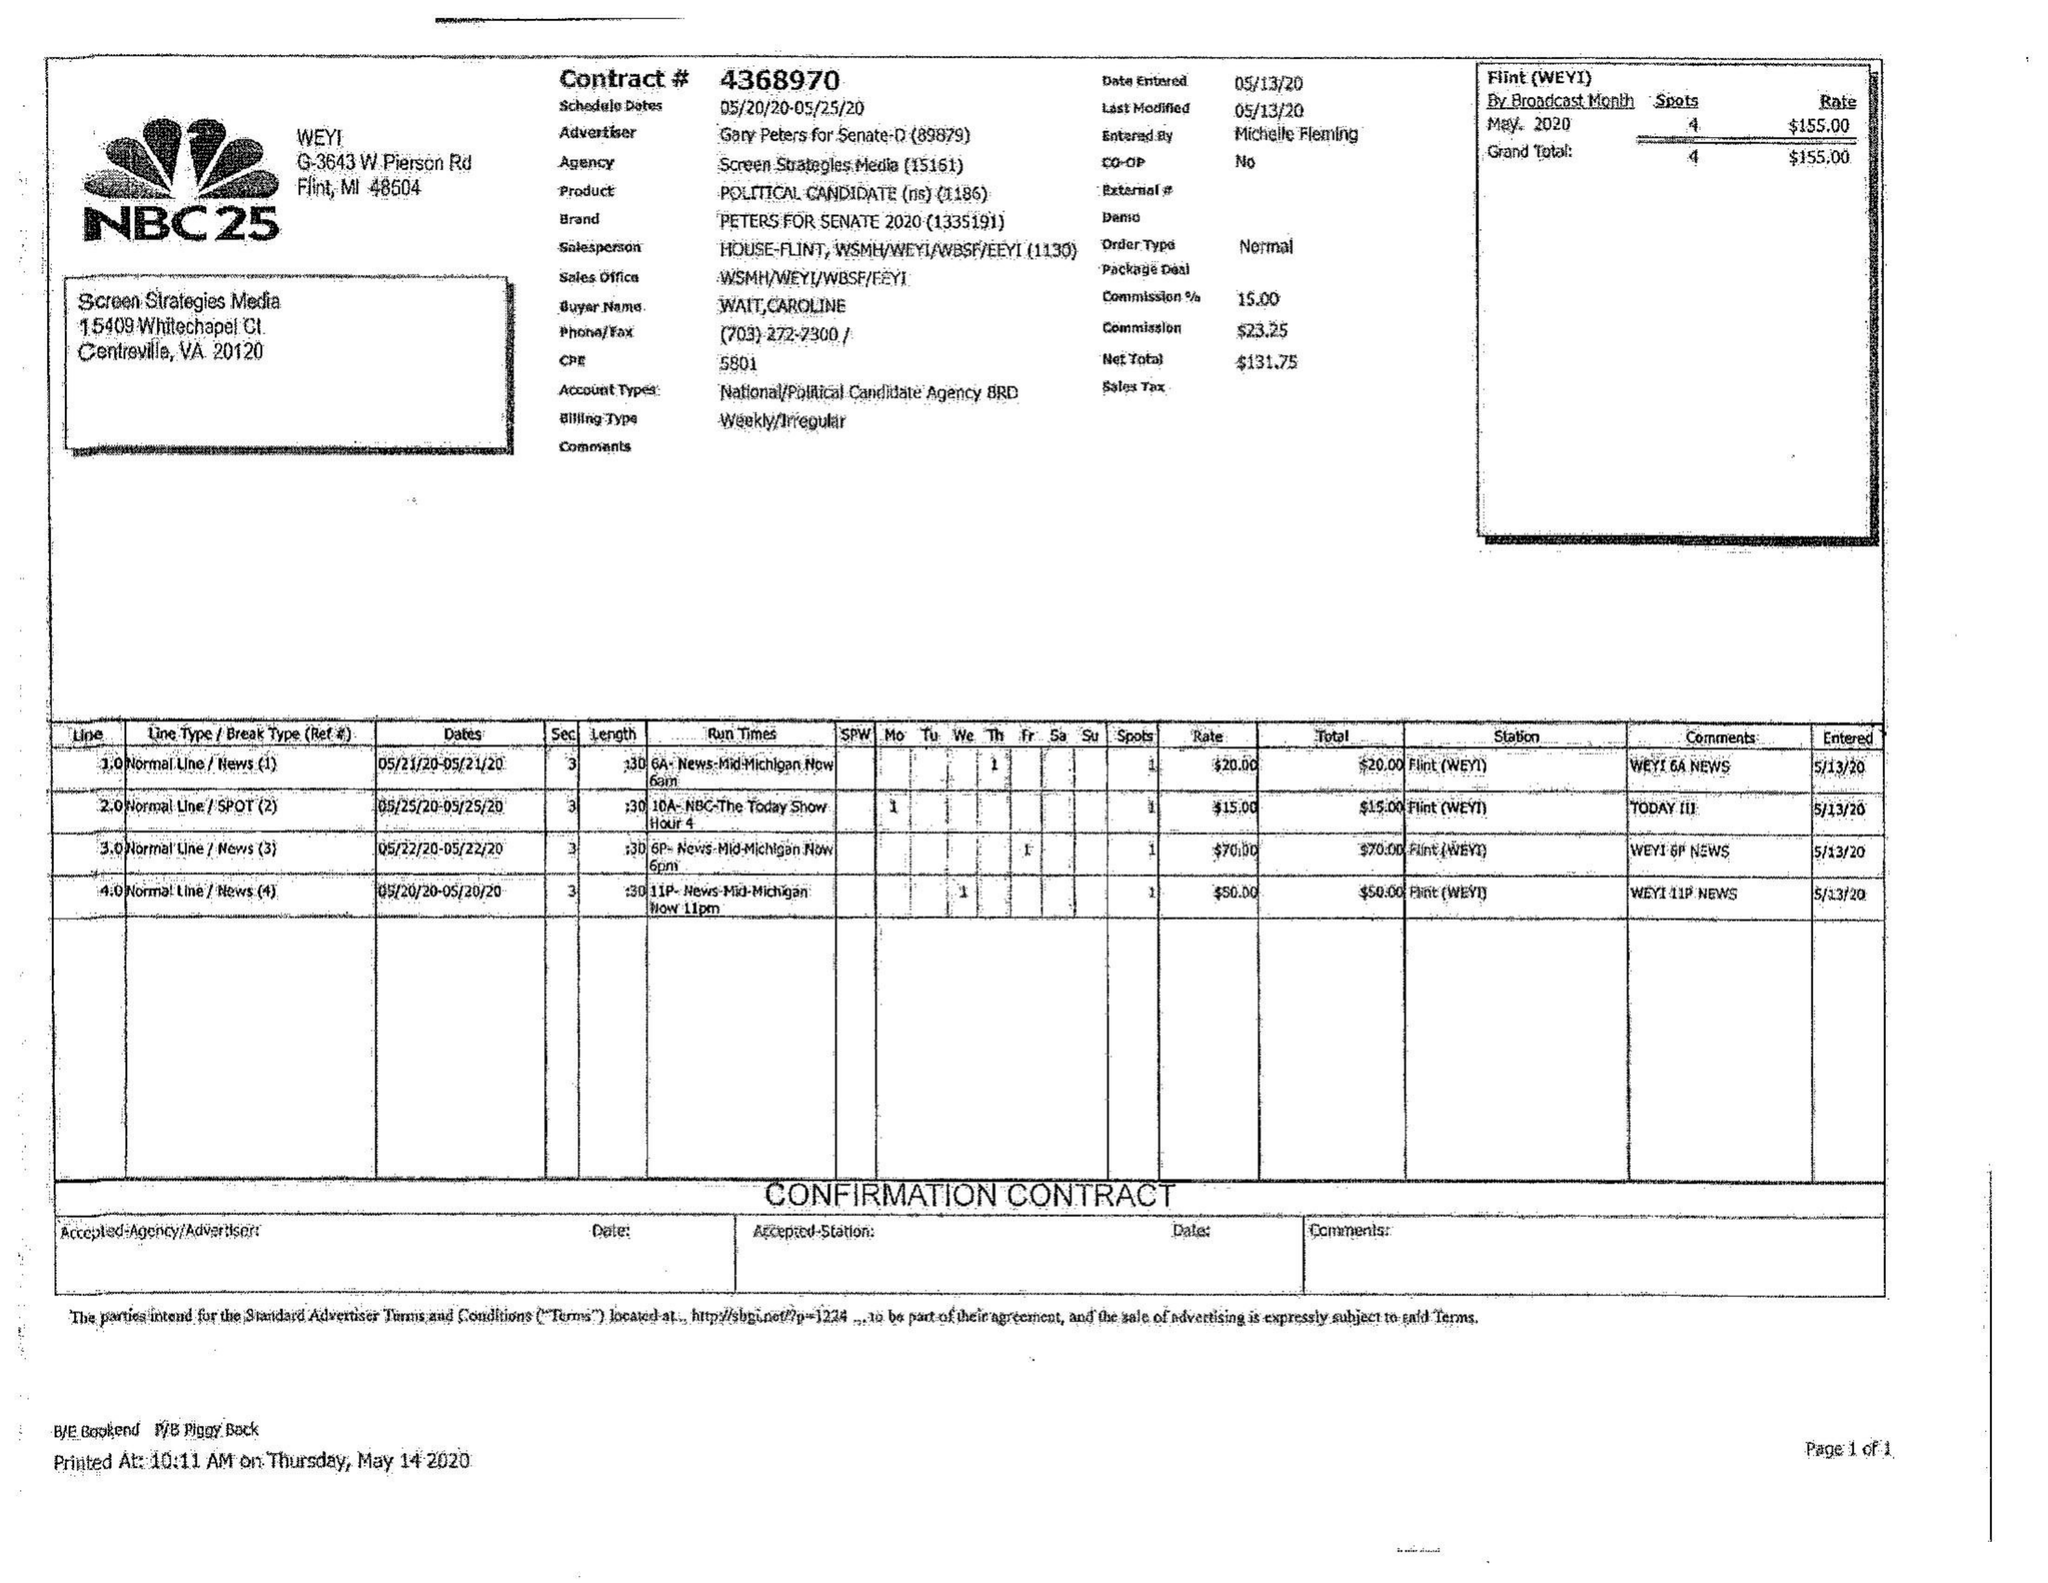What is the value for the flight_from?
Answer the question using a single word or phrase. 05/20/20 